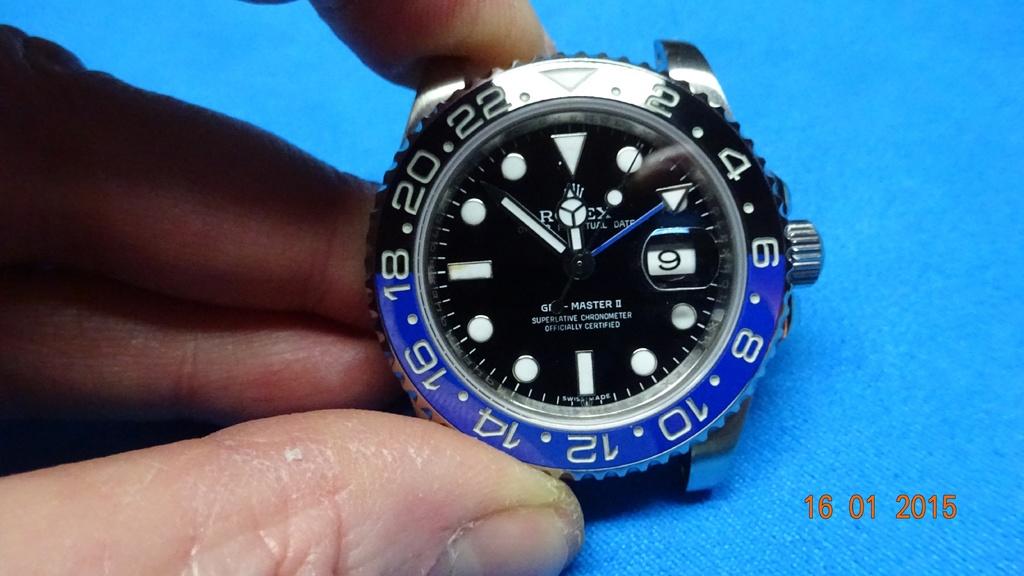When is this photo taken?
Ensure brevity in your answer.  16 01 2015. What is the time shown?
Offer a terse response. 10:10. 